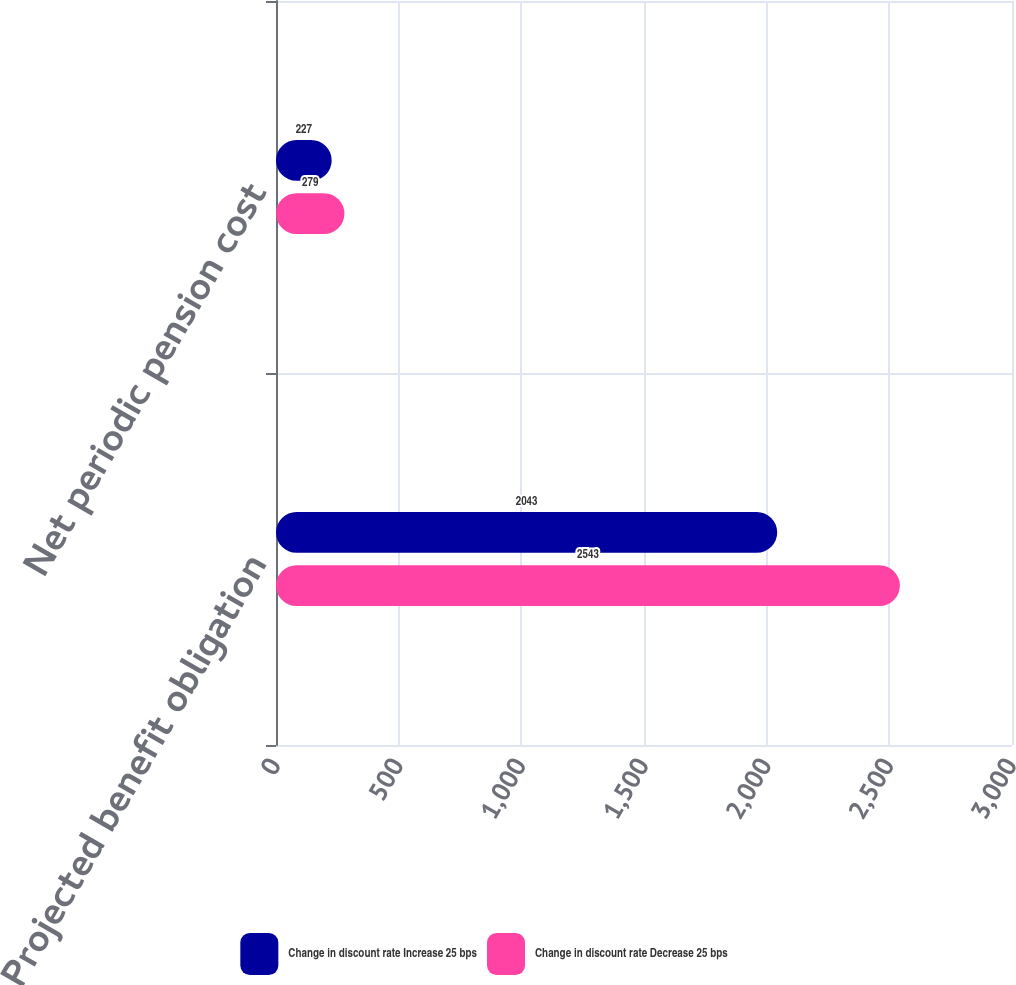Convert chart to OTSL. <chart><loc_0><loc_0><loc_500><loc_500><stacked_bar_chart><ecel><fcel>Projected benefit obligation<fcel>Net periodic pension cost<nl><fcel>Change in discount rate Increase 25 bps<fcel>2043<fcel>227<nl><fcel>Change in discount rate Decrease 25 bps<fcel>2543<fcel>279<nl></chart> 